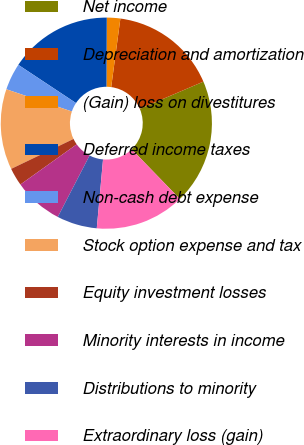Convert chart to OTSL. <chart><loc_0><loc_0><loc_500><loc_500><pie_chart><fcel>Net income<fcel>Depreciation and amortization<fcel>(Gain) loss on divestitures<fcel>Deferred income taxes<fcel>Non-cash debt expense<fcel>Stock option expense and tax<fcel>Equity investment losses<fcel>Minority interests in income<fcel>Distributions to minority<fcel>Extraordinary loss (gain)<nl><fcel>19.18%<fcel>16.44%<fcel>2.06%<fcel>15.75%<fcel>4.11%<fcel>12.33%<fcel>2.74%<fcel>7.53%<fcel>6.16%<fcel>13.7%<nl></chart> 